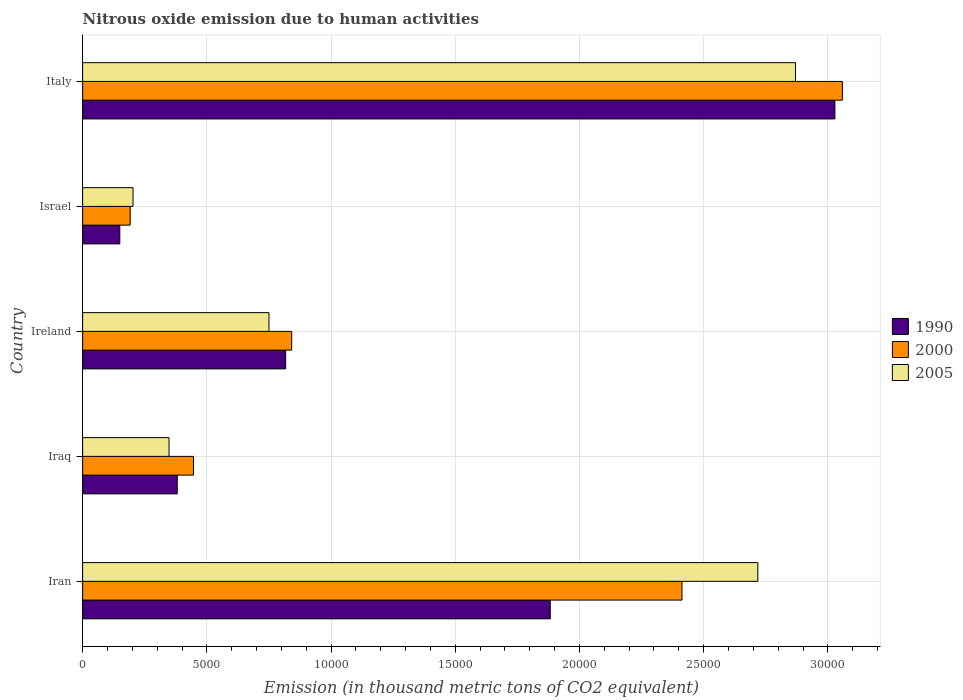How many different coloured bars are there?
Provide a short and direct response. 3. Are the number of bars on each tick of the Y-axis equal?
Offer a terse response. Yes. How many bars are there on the 5th tick from the bottom?
Keep it short and to the point. 3. What is the label of the 4th group of bars from the top?
Give a very brief answer. Iraq. What is the amount of nitrous oxide emitted in 2000 in Iraq?
Provide a succinct answer. 4462.3. Across all countries, what is the maximum amount of nitrous oxide emitted in 1990?
Provide a short and direct response. 3.03e+04. Across all countries, what is the minimum amount of nitrous oxide emitted in 2000?
Offer a very short reply. 1913.7. What is the total amount of nitrous oxide emitted in 2000 in the graph?
Ensure brevity in your answer.  6.95e+04. What is the difference between the amount of nitrous oxide emitted in 1990 in Israel and that in Italy?
Your response must be concise. -2.88e+04. What is the difference between the amount of nitrous oxide emitted in 1990 in Iraq and the amount of nitrous oxide emitted in 2005 in Iran?
Ensure brevity in your answer.  -2.34e+04. What is the average amount of nitrous oxide emitted in 2000 per country?
Give a very brief answer. 1.39e+04. What is the difference between the amount of nitrous oxide emitted in 1990 and amount of nitrous oxide emitted in 2000 in Ireland?
Your answer should be very brief. -243.6. What is the ratio of the amount of nitrous oxide emitted in 2005 in Ireland to that in Israel?
Offer a terse response. 3.7. Is the amount of nitrous oxide emitted in 2005 in Iran less than that in Israel?
Your response must be concise. No. What is the difference between the highest and the second highest amount of nitrous oxide emitted in 2005?
Provide a succinct answer. 1517.2. What is the difference between the highest and the lowest amount of nitrous oxide emitted in 1990?
Provide a succinct answer. 2.88e+04. Is it the case that in every country, the sum of the amount of nitrous oxide emitted in 1990 and amount of nitrous oxide emitted in 2000 is greater than the amount of nitrous oxide emitted in 2005?
Your answer should be very brief. Yes. How many countries are there in the graph?
Keep it short and to the point. 5. Does the graph contain any zero values?
Provide a succinct answer. No. Where does the legend appear in the graph?
Your answer should be compact. Center right. What is the title of the graph?
Provide a short and direct response. Nitrous oxide emission due to human activities. What is the label or title of the X-axis?
Provide a succinct answer. Emission (in thousand metric tons of CO2 equivalent). What is the Emission (in thousand metric tons of CO2 equivalent) of 1990 in Iran?
Make the answer very short. 1.88e+04. What is the Emission (in thousand metric tons of CO2 equivalent) in 2000 in Iran?
Give a very brief answer. 2.41e+04. What is the Emission (in thousand metric tons of CO2 equivalent) in 2005 in Iran?
Ensure brevity in your answer.  2.72e+04. What is the Emission (in thousand metric tons of CO2 equivalent) of 1990 in Iraq?
Give a very brief answer. 3808.9. What is the Emission (in thousand metric tons of CO2 equivalent) of 2000 in Iraq?
Keep it short and to the point. 4462.3. What is the Emission (in thousand metric tons of CO2 equivalent) of 2005 in Iraq?
Make the answer very short. 3478.3. What is the Emission (in thousand metric tons of CO2 equivalent) of 1990 in Ireland?
Give a very brief answer. 8172.1. What is the Emission (in thousand metric tons of CO2 equivalent) of 2000 in Ireland?
Ensure brevity in your answer.  8415.7. What is the Emission (in thousand metric tons of CO2 equivalent) in 2005 in Ireland?
Provide a short and direct response. 7501.6. What is the Emission (in thousand metric tons of CO2 equivalent) of 1990 in Israel?
Provide a succinct answer. 1495.8. What is the Emission (in thousand metric tons of CO2 equivalent) of 2000 in Israel?
Give a very brief answer. 1913.7. What is the Emission (in thousand metric tons of CO2 equivalent) in 2005 in Israel?
Make the answer very short. 2029. What is the Emission (in thousand metric tons of CO2 equivalent) in 1990 in Italy?
Offer a terse response. 3.03e+04. What is the Emission (in thousand metric tons of CO2 equivalent) of 2000 in Italy?
Ensure brevity in your answer.  3.06e+04. What is the Emission (in thousand metric tons of CO2 equivalent) in 2005 in Italy?
Provide a short and direct response. 2.87e+04. Across all countries, what is the maximum Emission (in thousand metric tons of CO2 equivalent) of 1990?
Offer a very short reply. 3.03e+04. Across all countries, what is the maximum Emission (in thousand metric tons of CO2 equivalent) in 2000?
Your answer should be very brief. 3.06e+04. Across all countries, what is the maximum Emission (in thousand metric tons of CO2 equivalent) of 2005?
Provide a succinct answer. 2.87e+04. Across all countries, what is the minimum Emission (in thousand metric tons of CO2 equivalent) in 1990?
Offer a very short reply. 1495.8. Across all countries, what is the minimum Emission (in thousand metric tons of CO2 equivalent) in 2000?
Make the answer very short. 1913.7. Across all countries, what is the minimum Emission (in thousand metric tons of CO2 equivalent) of 2005?
Make the answer very short. 2029. What is the total Emission (in thousand metric tons of CO2 equivalent) in 1990 in the graph?
Provide a succinct answer. 6.26e+04. What is the total Emission (in thousand metric tons of CO2 equivalent) in 2000 in the graph?
Give a very brief answer. 6.95e+04. What is the total Emission (in thousand metric tons of CO2 equivalent) of 2005 in the graph?
Offer a terse response. 6.89e+04. What is the difference between the Emission (in thousand metric tons of CO2 equivalent) of 1990 in Iran and that in Iraq?
Your answer should be very brief. 1.50e+04. What is the difference between the Emission (in thousand metric tons of CO2 equivalent) in 2000 in Iran and that in Iraq?
Give a very brief answer. 1.97e+04. What is the difference between the Emission (in thousand metric tons of CO2 equivalent) in 2005 in Iran and that in Iraq?
Your answer should be very brief. 2.37e+04. What is the difference between the Emission (in thousand metric tons of CO2 equivalent) of 1990 in Iran and that in Ireland?
Offer a terse response. 1.07e+04. What is the difference between the Emission (in thousand metric tons of CO2 equivalent) in 2000 in Iran and that in Ireland?
Your answer should be very brief. 1.57e+04. What is the difference between the Emission (in thousand metric tons of CO2 equivalent) in 2005 in Iran and that in Ireland?
Provide a succinct answer. 1.97e+04. What is the difference between the Emission (in thousand metric tons of CO2 equivalent) of 1990 in Iran and that in Israel?
Offer a very short reply. 1.73e+04. What is the difference between the Emission (in thousand metric tons of CO2 equivalent) in 2000 in Iran and that in Israel?
Your answer should be very brief. 2.22e+04. What is the difference between the Emission (in thousand metric tons of CO2 equivalent) of 2005 in Iran and that in Israel?
Offer a very short reply. 2.52e+04. What is the difference between the Emission (in thousand metric tons of CO2 equivalent) of 1990 in Iran and that in Italy?
Give a very brief answer. -1.15e+04. What is the difference between the Emission (in thousand metric tons of CO2 equivalent) of 2000 in Iran and that in Italy?
Offer a terse response. -6455.9. What is the difference between the Emission (in thousand metric tons of CO2 equivalent) in 2005 in Iran and that in Italy?
Provide a short and direct response. -1517.2. What is the difference between the Emission (in thousand metric tons of CO2 equivalent) of 1990 in Iraq and that in Ireland?
Offer a very short reply. -4363.2. What is the difference between the Emission (in thousand metric tons of CO2 equivalent) of 2000 in Iraq and that in Ireland?
Offer a very short reply. -3953.4. What is the difference between the Emission (in thousand metric tons of CO2 equivalent) of 2005 in Iraq and that in Ireland?
Offer a terse response. -4023.3. What is the difference between the Emission (in thousand metric tons of CO2 equivalent) of 1990 in Iraq and that in Israel?
Keep it short and to the point. 2313.1. What is the difference between the Emission (in thousand metric tons of CO2 equivalent) in 2000 in Iraq and that in Israel?
Give a very brief answer. 2548.6. What is the difference between the Emission (in thousand metric tons of CO2 equivalent) of 2005 in Iraq and that in Israel?
Your answer should be very brief. 1449.3. What is the difference between the Emission (in thousand metric tons of CO2 equivalent) of 1990 in Iraq and that in Italy?
Your response must be concise. -2.65e+04. What is the difference between the Emission (in thousand metric tons of CO2 equivalent) in 2000 in Iraq and that in Italy?
Keep it short and to the point. -2.61e+04. What is the difference between the Emission (in thousand metric tons of CO2 equivalent) in 2005 in Iraq and that in Italy?
Your answer should be very brief. -2.52e+04. What is the difference between the Emission (in thousand metric tons of CO2 equivalent) of 1990 in Ireland and that in Israel?
Provide a succinct answer. 6676.3. What is the difference between the Emission (in thousand metric tons of CO2 equivalent) in 2000 in Ireland and that in Israel?
Offer a terse response. 6502. What is the difference between the Emission (in thousand metric tons of CO2 equivalent) in 2005 in Ireland and that in Israel?
Your answer should be very brief. 5472.6. What is the difference between the Emission (in thousand metric tons of CO2 equivalent) of 1990 in Ireland and that in Italy?
Keep it short and to the point. -2.21e+04. What is the difference between the Emission (in thousand metric tons of CO2 equivalent) in 2000 in Ireland and that in Italy?
Give a very brief answer. -2.22e+04. What is the difference between the Emission (in thousand metric tons of CO2 equivalent) of 2005 in Ireland and that in Italy?
Your answer should be compact. -2.12e+04. What is the difference between the Emission (in thousand metric tons of CO2 equivalent) in 1990 in Israel and that in Italy?
Keep it short and to the point. -2.88e+04. What is the difference between the Emission (in thousand metric tons of CO2 equivalent) in 2000 in Israel and that in Italy?
Offer a terse response. -2.87e+04. What is the difference between the Emission (in thousand metric tons of CO2 equivalent) in 2005 in Israel and that in Italy?
Make the answer very short. -2.67e+04. What is the difference between the Emission (in thousand metric tons of CO2 equivalent) in 1990 in Iran and the Emission (in thousand metric tons of CO2 equivalent) in 2000 in Iraq?
Make the answer very short. 1.44e+04. What is the difference between the Emission (in thousand metric tons of CO2 equivalent) of 1990 in Iran and the Emission (in thousand metric tons of CO2 equivalent) of 2005 in Iraq?
Offer a terse response. 1.53e+04. What is the difference between the Emission (in thousand metric tons of CO2 equivalent) in 2000 in Iran and the Emission (in thousand metric tons of CO2 equivalent) in 2005 in Iraq?
Offer a very short reply. 2.06e+04. What is the difference between the Emission (in thousand metric tons of CO2 equivalent) in 1990 in Iran and the Emission (in thousand metric tons of CO2 equivalent) in 2000 in Ireland?
Provide a succinct answer. 1.04e+04. What is the difference between the Emission (in thousand metric tons of CO2 equivalent) in 1990 in Iran and the Emission (in thousand metric tons of CO2 equivalent) in 2005 in Ireland?
Keep it short and to the point. 1.13e+04. What is the difference between the Emission (in thousand metric tons of CO2 equivalent) in 2000 in Iran and the Emission (in thousand metric tons of CO2 equivalent) in 2005 in Ireland?
Provide a succinct answer. 1.66e+04. What is the difference between the Emission (in thousand metric tons of CO2 equivalent) in 1990 in Iran and the Emission (in thousand metric tons of CO2 equivalent) in 2000 in Israel?
Give a very brief answer. 1.69e+04. What is the difference between the Emission (in thousand metric tons of CO2 equivalent) of 1990 in Iran and the Emission (in thousand metric tons of CO2 equivalent) of 2005 in Israel?
Your response must be concise. 1.68e+04. What is the difference between the Emission (in thousand metric tons of CO2 equivalent) of 2000 in Iran and the Emission (in thousand metric tons of CO2 equivalent) of 2005 in Israel?
Offer a terse response. 2.21e+04. What is the difference between the Emission (in thousand metric tons of CO2 equivalent) in 1990 in Iran and the Emission (in thousand metric tons of CO2 equivalent) in 2000 in Italy?
Offer a very short reply. -1.18e+04. What is the difference between the Emission (in thousand metric tons of CO2 equivalent) in 1990 in Iran and the Emission (in thousand metric tons of CO2 equivalent) in 2005 in Italy?
Offer a very short reply. -9872.8. What is the difference between the Emission (in thousand metric tons of CO2 equivalent) of 2000 in Iran and the Emission (in thousand metric tons of CO2 equivalent) of 2005 in Italy?
Give a very brief answer. -4569.8. What is the difference between the Emission (in thousand metric tons of CO2 equivalent) in 1990 in Iraq and the Emission (in thousand metric tons of CO2 equivalent) in 2000 in Ireland?
Provide a short and direct response. -4606.8. What is the difference between the Emission (in thousand metric tons of CO2 equivalent) in 1990 in Iraq and the Emission (in thousand metric tons of CO2 equivalent) in 2005 in Ireland?
Offer a very short reply. -3692.7. What is the difference between the Emission (in thousand metric tons of CO2 equivalent) of 2000 in Iraq and the Emission (in thousand metric tons of CO2 equivalent) of 2005 in Ireland?
Ensure brevity in your answer.  -3039.3. What is the difference between the Emission (in thousand metric tons of CO2 equivalent) in 1990 in Iraq and the Emission (in thousand metric tons of CO2 equivalent) in 2000 in Israel?
Offer a terse response. 1895.2. What is the difference between the Emission (in thousand metric tons of CO2 equivalent) of 1990 in Iraq and the Emission (in thousand metric tons of CO2 equivalent) of 2005 in Israel?
Give a very brief answer. 1779.9. What is the difference between the Emission (in thousand metric tons of CO2 equivalent) in 2000 in Iraq and the Emission (in thousand metric tons of CO2 equivalent) in 2005 in Israel?
Keep it short and to the point. 2433.3. What is the difference between the Emission (in thousand metric tons of CO2 equivalent) of 1990 in Iraq and the Emission (in thousand metric tons of CO2 equivalent) of 2000 in Italy?
Keep it short and to the point. -2.68e+04. What is the difference between the Emission (in thousand metric tons of CO2 equivalent) of 1990 in Iraq and the Emission (in thousand metric tons of CO2 equivalent) of 2005 in Italy?
Offer a terse response. -2.49e+04. What is the difference between the Emission (in thousand metric tons of CO2 equivalent) in 2000 in Iraq and the Emission (in thousand metric tons of CO2 equivalent) in 2005 in Italy?
Provide a succinct answer. -2.42e+04. What is the difference between the Emission (in thousand metric tons of CO2 equivalent) of 1990 in Ireland and the Emission (in thousand metric tons of CO2 equivalent) of 2000 in Israel?
Provide a short and direct response. 6258.4. What is the difference between the Emission (in thousand metric tons of CO2 equivalent) in 1990 in Ireland and the Emission (in thousand metric tons of CO2 equivalent) in 2005 in Israel?
Your answer should be compact. 6143.1. What is the difference between the Emission (in thousand metric tons of CO2 equivalent) in 2000 in Ireland and the Emission (in thousand metric tons of CO2 equivalent) in 2005 in Israel?
Ensure brevity in your answer.  6386.7. What is the difference between the Emission (in thousand metric tons of CO2 equivalent) in 1990 in Ireland and the Emission (in thousand metric tons of CO2 equivalent) in 2000 in Italy?
Ensure brevity in your answer.  -2.24e+04. What is the difference between the Emission (in thousand metric tons of CO2 equivalent) of 1990 in Ireland and the Emission (in thousand metric tons of CO2 equivalent) of 2005 in Italy?
Make the answer very short. -2.05e+04. What is the difference between the Emission (in thousand metric tons of CO2 equivalent) of 2000 in Ireland and the Emission (in thousand metric tons of CO2 equivalent) of 2005 in Italy?
Provide a short and direct response. -2.03e+04. What is the difference between the Emission (in thousand metric tons of CO2 equivalent) in 1990 in Israel and the Emission (in thousand metric tons of CO2 equivalent) in 2000 in Italy?
Offer a very short reply. -2.91e+04. What is the difference between the Emission (in thousand metric tons of CO2 equivalent) in 1990 in Israel and the Emission (in thousand metric tons of CO2 equivalent) in 2005 in Italy?
Give a very brief answer. -2.72e+04. What is the difference between the Emission (in thousand metric tons of CO2 equivalent) of 2000 in Israel and the Emission (in thousand metric tons of CO2 equivalent) of 2005 in Italy?
Provide a short and direct response. -2.68e+04. What is the average Emission (in thousand metric tons of CO2 equivalent) in 1990 per country?
Your response must be concise. 1.25e+04. What is the average Emission (in thousand metric tons of CO2 equivalent) of 2000 per country?
Ensure brevity in your answer.  1.39e+04. What is the average Emission (in thousand metric tons of CO2 equivalent) of 2005 per country?
Your response must be concise. 1.38e+04. What is the difference between the Emission (in thousand metric tons of CO2 equivalent) in 1990 and Emission (in thousand metric tons of CO2 equivalent) in 2000 in Iran?
Provide a succinct answer. -5303. What is the difference between the Emission (in thousand metric tons of CO2 equivalent) in 1990 and Emission (in thousand metric tons of CO2 equivalent) in 2005 in Iran?
Ensure brevity in your answer.  -8355.6. What is the difference between the Emission (in thousand metric tons of CO2 equivalent) in 2000 and Emission (in thousand metric tons of CO2 equivalent) in 2005 in Iran?
Ensure brevity in your answer.  -3052.6. What is the difference between the Emission (in thousand metric tons of CO2 equivalent) of 1990 and Emission (in thousand metric tons of CO2 equivalent) of 2000 in Iraq?
Your response must be concise. -653.4. What is the difference between the Emission (in thousand metric tons of CO2 equivalent) in 1990 and Emission (in thousand metric tons of CO2 equivalent) in 2005 in Iraq?
Keep it short and to the point. 330.6. What is the difference between the Emission (in thousand metric tons of CO2 equivalent) of 2000 and Emission (in thousand metric tons of CO2 equivalent) of 2005 in Iraq?
Offer a very short reply. 984. What is the difference between the Emission (in thousand metric tons of CO2 equivalent) of 1990 and Emission (in thousand metric tons of CO2 equivalent) of 2000 in Ireland?
Your response must be concise. -243.6. What is the difference between the Emission (in thousand metric tons of CO2 equivalent) of 1990 and Emission (in thousand metric tons of CO2 equivalent) of 2005 in Ireland?
Make the answer very short. 670.5. What is the difference between the Emission (in thousand metric tons of CO2 equivalent) of 2000 and Emission (in thousand metric tons of CO2 equivalent) of 2005 in Ireland?
Offer a very short reply. 914.1. What is the difference between the Emission (in thousand metric tons of CO2 equivalent) of 1990 and Emission (in thousand metric tons of CO2 equivalent) of 2000 in Israel?
Offer a terse response. -417.9. What is the difference between the Emission (in thousand metric tons of CO2 equivalent) of 1990 and Emission (in thousand metric tons of CO2 equivalent) of 2005 in Israel?
Give a very brief answer. -533.2. What is the difference between the Emission (in thousand metric tons of CO2 equivalent) of 2000 and Emission (in thousand metric tons of CO2 equivalent) of 2005 in Israel?
Your answer should be compact. -115.3. What is the difference between the Emission (in thousand metric tons of CO2 equivalent) in 1990 and Emission (in thousand metric tons of CO2 equivalent) in 2000 in Italy?
Give a very brief answer. -301.2. What is the difference between the Emission (in thousand metric tons of CO2 equivalent) of 1990 and Emission (in thousand metric tons of CO2 equivalent) of 2005 in Italy?
Offer a very short reply. 1584.9. What is the difference between the Emission (in thousand metric tons of CO2 equivalent) in 2000 and Emission (in thousand metric tons of CO2 equivalent) in 2005 in Italy?
Provide a short and direct response. 1886.1. What is the ratio of the Emission (in thousand metric tons of CO2 equivalent) of 1990 in Iran to that in Iraq?
Offer a terse response. 4.94. What is the ratio of the Emission (in thousand metric tons of CO2 equivalent) in 2000 in Iran to that in Iraq?
Provide a short and direct response. 5.41. What is the ratio of the Emission (in thousand metric tons of CO2 equivalent) in 2005 in Iran to that in Iraq?
Your response must be concise. 7.81. What is the ratio of the Emission (in thousand metric tons of CO2 equivalent) of 1990 in Iran to that in Ireland?
Your answer should be compact. 2.3. What is the ratio of the Emission (in thousand metric tons of CO2 equivalent) of 2000 in Iran to that in Ireland?
Offer a terse response. 2.87. What is the ratio of the Emission (in thousand metric tons of CO2 equivalent) in 2005 in Iran to that in Ireland?
Provide a succinct answer. 3.62. What is the ratio of the Emission (in thousand metric tons of CO2 equivalent) of 1990 in Iran to that in Israel?
Offer a terse response. 12.59. What is the ratio of the Emission (in thousand metric tons of CO2 equivalent) in 2000 in Iran to that in Israel?
Your answer should be compact. 12.61. What is the ratio of the Emission (in thousand metric tons of CO2 equivalent) in 2005 in Iran to that in Israel?
Your answer should be compact. 13.4. What is the ratio of the Emission (in thousand metric tons of CO2 equivalent) of 1990 in Iran to that in Italy?
Keep it short and to the point. 0.62. What is the ratio of the Emission (in thousand metric tons of CO2 equivalent) in 2000 in Iran to that in Italy?
Provide a short and direct response. 0.79. What is the ratio of the Emission (in thousand metric tons of CO2 equivalent) in 2005 in Iran to that in Italy?
Your response must be concise. 0.95. What is the ratio of the Emission (in thousand metric tons of CO2 equivalent) in 1990 in Iraq to that in Ireland?
Offer a terse response. 0.47. What is the ratio of the Emission (in thousand metric tons of CO2 equivalent) of 2000 in Iraq to that in Ireland?
Your response must be concise. 0.53. What is the ratio of the Emission (in thousand metric tons of CO2 equivalent) in 2005 in Iraq to that in Ireland?
Provide a short and direct response. 0.46. What is the ratio of the Emission (in thousand metric tons of CO2 equivalent) in 1990 in Iraq to that in Israel?
Make the answer very short. 2.55. What is the ratio of the Emission (in thousand metric tons of CO2 equivalent) in 2000 in Iraq to that in Israel?
Offer a very short reply. 2.33. What is the ratio of the Emission (in thousand metric tons of CO2 equivalent) in 2005 in Iraq to that in Israel?
Offer a very short reply. 1.71. What is the ratio of the Emission (in thousand metric tons of CO2 equivalent) of 1990 in Iraq to that in Italy?
Your answer should be compact. 0.13. What is the ratio of the Emission (in thousand metric tons of CO2 equivalent) of 2000 in Iraq to that in Italy?
Ensure brevity in your answer.  0.15. What is the ratio of the Emission (in thousand metric tons of CO2 equivalent) in 2005 in Iraq to that in Italy?
Your answer should be compact. 0.12. What is the ratio of the Emission (in thousand metric tons of CO2 equivalent) in 1990 in Ireland to that in Israel?
Your answer should be very brief. 5.46. What is the ratio of the Emission (in thousand metric tons of CO2 equivalent) of 2000 in Ireland to that in Israel?
Keep it short and to the point. 4.4. What is the ratio of the Emission (in thousand metric tons of CO2 equivalent) of 2005 in Ireland to that in Israel?
Make the answer very short. 3.7. What is the ratio of the Emission (in thousand metric tons of CO2 equivalent) of 1990 in Ireland to that in Italy?
Your answer should be very brief. 0.27. What is the ratio of the Emission (in thousand metric tons of CO2 equivalent) of 2000 in Ireland to that in Italy?
Give a very brief answer. 0.28. What is the ratio of the Emission (in thousand metric tons of CO2 equivalent) of 2005 in Ireland to that in Italy?
Your response must be concise. 0.26. What is the ratio of the Emission (in thousand metric tons of CO2 equivalent) in 1990 in Israel to that in Italy?
Keep it short and to the point. 0.05. What is the ratio of the Emission (in thousand metric tons of CO2 equivalent) of 2000 in Israel to that in Italy?
Your response must be concise. 0.06. What is the ratio of the Emission (in thousand metric tons of CO2 equivalent) of 2005 in Israel to that in Italy?
Provide a short and direct response. 0.07. What is the difference between the highest and the second highest Emission (in thousand metric tons of CO2 equivalent) in 1990?
Provide a short and direct response. 1.15e+04. What is the difference between the highest and the second highest Emission (in thousand metric tons of CO2 equivalent) in 2000?
Your answer should be compact. 6455.9. What is the difference between the highest and the second highest Emission (in thousand metric tons of CO2 equivalent) in 2005?
Offer a very short reply. 1517.2. What is the difference between the highest and the lowest Emission (in thousand metric tons of CO2 equivalent) of 1990?
Offer a terse response. 2.88e+04. What is the difference between the highest and the lowest Emission (in thousand metric tons of CO2 equivalent) in 2000?
Give a very brief answer. 2.87e+04. What is the difference between the highest and the lowest Emission (in thousand metric tons of CO2 equivalent) of 2005?
Your answer should be compact. 2.67e+04. 